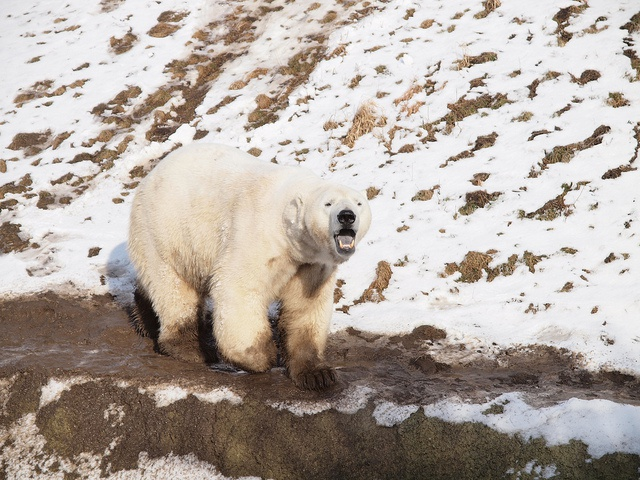Describe the objects in this image and their specific colors. I can see a bear in lightgray, tan, and black tones in this image. 